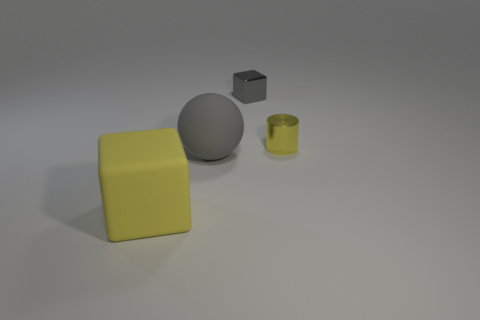There is a block that is the same color as the big matte sphere; what is its material?
Ensure brevity in your answer.  Metal. Is there a yellow rubber object of the same shape as the small yellow metal thing?
Provide a short and direct response. No. How many tiny yellow shiny cylinders are behind the large block?
Provide a succinct answer. 1. There is a tiny object that is on the left side of the tiny thing in front of the gray metal block; what is it made of?
Give a very brief answer. Metal. What is the material of the yellow cylinder that is the same size as the gray block?
Offer a terse response. Metal. Is there a gray thing of the same size as the matte block?
Ensure brevity in your answer.  Yes. What color is the small thing that is on the right side of the gray block?
Ensure brevity in your answer.  Yellow. Are there any yellow objects behind the big rubber object that is behind the yellow cube?
Provide a short and direct response. Yes. How many other things are there of the same color as the tiny metallic cylinder?
Offer a terse response. 1. Do the yellow thing that is on the right side of the sphere and the metal thing behind the yellow metallic thing have the same size?
Keep it short and to the point. Yes. 